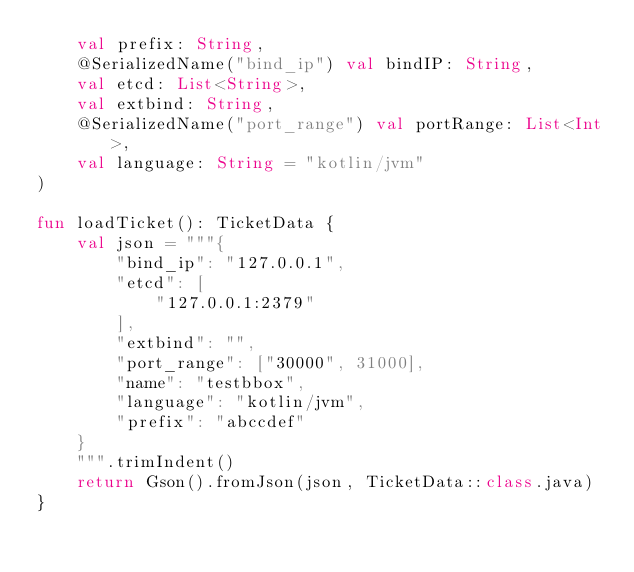Convert code to text. <code><loc_0><loc_0><loc_500><loc_500><_Kotlin_>    val prefix: String,
    @SerializedName("bind_ip") val bindIP: String,
    val etcd: List<String>,
    val extbind: String,
    @SerializedName("port_range") val portRange: List<Int>,
    val language: String = "kotlin/jvm"
)

fun loadTicket(): TicketData {
    val json = """{
        "bind_ip": "127.0.0.1",
        "etcd": [
            "127.0.0.1:2379"
        ],
        "extbind": "",
        "port_range": ["30000", 31000],
        "name": "testbbox",
        "language": "kotlin/jvm",
        "prefix": "abccdef"
    }
    """.trimIndent()
    return Gson().fromJson(json, TicketData::class.java)
}</code> 